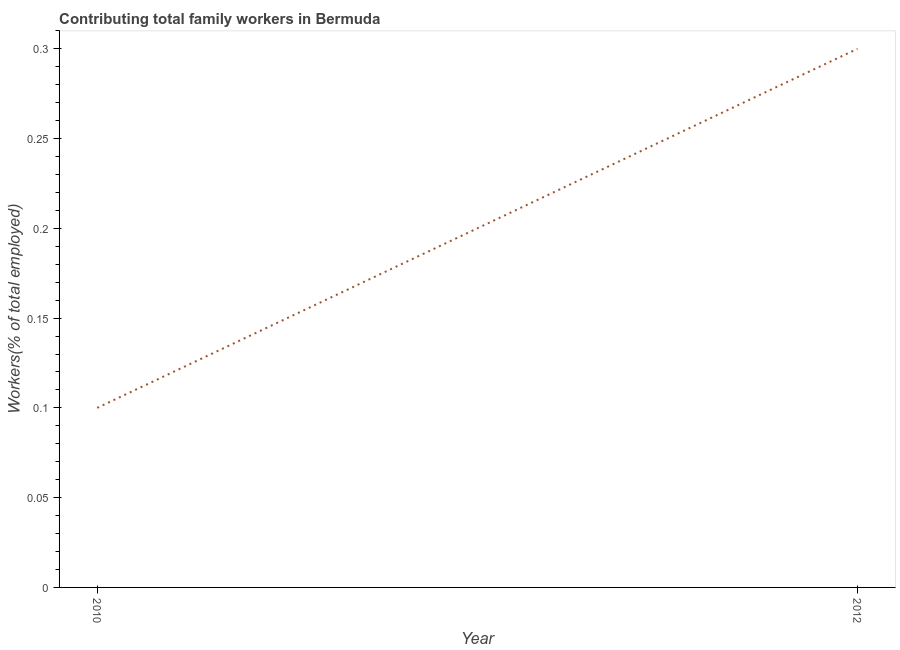What is the contributing family workers in 2010?
Your answer should be very brief. 0.1. Across all years, what is the maximum contributing family workers?
Provide a short and direct response. 0.3. Across all years, what is the minimum contributing family workers?
Make the answer very short. 0.1. In which year was the contributing family workers maximum?
Offer a very short reply. 2012. In which year was the contributing family workers minimum?
Ensure brevity in your answer.  2010. What is the sum of the contributing family workers?
Your answer should be very brief. 0.4. What is the difference between the contributing family workers in 2010 and 2012?
Keep it short and to the point. -0.2. What is the average contributing family workers per year?
Your answer should be very brief. 0.2. What is the median contributing family workers?
Ensure brevity in your answer.  0.2. Do a majority of the years between 2010 and 2012 (inclusive) have contributing family workers greater than 0.24000000000000002 %?
Your answer should be compact. No. What is the ratio of the contributing family workers in 2010 to that in 2012?
Offer a terse response. 0.33. In how many years, is the contributing family workers greater than the average contributing family workers taken over all years?
Give a very brief answer. 1. How many lines are there?
Provide a short and direct response. 1. How many years are there in the graph?
Offer a terse response. 2. Are the values on the major ticks of Y-axis written in scientific E-notation?
Offer a very short reply. No. Does the graph contain any zero values?
Your answer should be compact. No. What is the title of the graph?
Offer a terse response. Contributing total family workers in Bermuda. What is the label or title of the X-axis?
Ensure brevity in your answer.  Year. What is the label or title of the Y-axis?
Your answer should be compact. Workers(% of total employed). What is the Workers(% of total employed) of 2010?
Offer a terse response. 0.1. What is the Workers(% of total employed) of 2012?
Give a very brief answer. 0.3. What is the difference between the Workers(% of total employed) in 2010 and 2012?
Provide a succinct answer. -0.2. What is the ratio of the Workers(% of total employed) in 2010 to that in 2012?
Give a very brief answer. 0.33. 